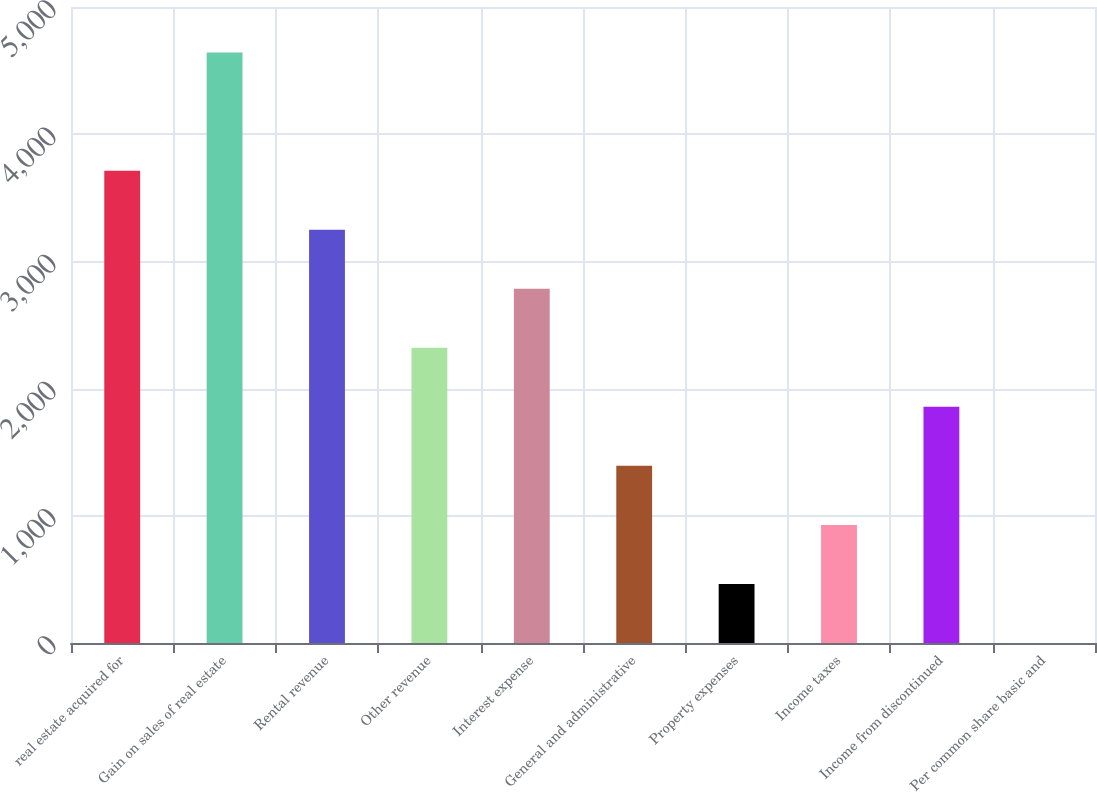<chart> <loc_0><loc_0><loc_500><loc_500><bar_chart><fcel>real estate acquired for<fcel>Gain on sales of real estate<fcel>Rental revenue<fcel>Other revenue<fcel>Interest expense<fcel>General and administrative<fcel>Property expenses<fcel>Income taxes<fcel>Income from discontinued<fcel>Per common share basic and<nl><fcel>3713.61<fcel>4642<fcel>3249.41<fcel>2321.01<fcel>2785.21<fcel>1392.61<fcel>464.21<fcel>928.41<fcel>1856.81<fcel>0.01<nl></chart> 